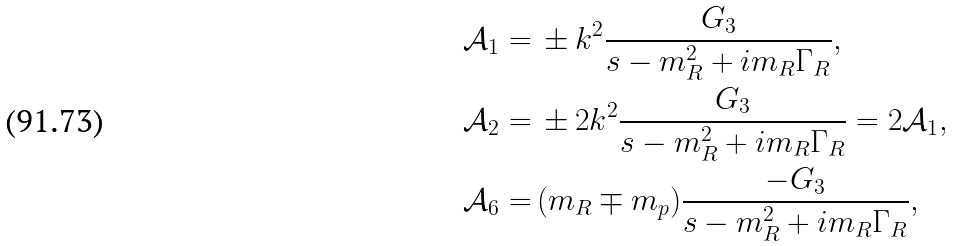Convert formula to latex. <formula><loc_0><loc_0><loc_500><loc_500>\mathcal { A } _ { 1 } = & \, \pm k ^ { 2 } \frac { G _ { 3 } } { s - m _ { R } ^ { 2 } + i m _ { R } \Gamma _ { R } } , \\ \mathcal { A } _ { 2 } = & \, \pm 2 k ^ { 2 } \frac { G _ { 3 } } { s - m _ { R } ^ { 2 } + i m _ { R } \Gamma _ { R } } = 2 \mathcal { A } _ { 1 } , \\ \mathcal { A } _ { 6 } = & \, ( m _ { R } \mp m _ { p } ) \frac { - G _ { 3 } } { s - m _ { R } ^ { 2 } + i m _ { R } \Gamma _ { R } } ,</formula> 